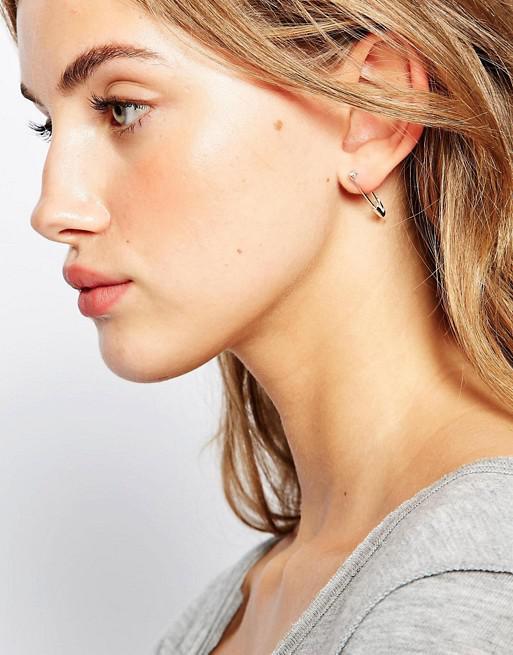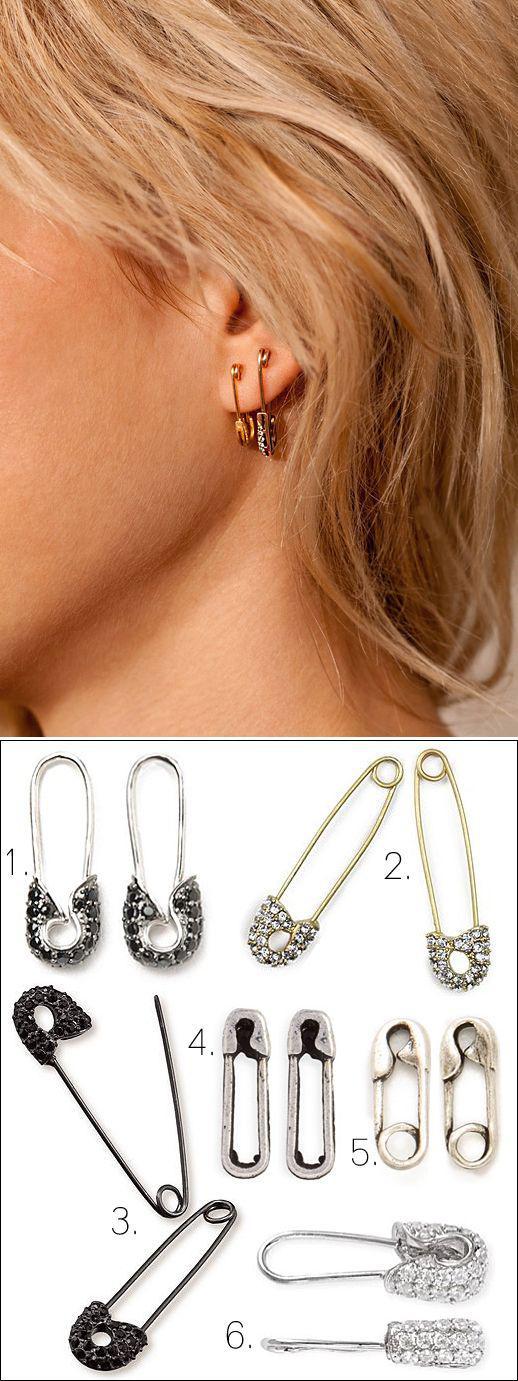The first image is the image on the left, the second image is the image on the right. Given the left and right images, does the statement "A person is wearing a safety pin in their ear in the image on the left." hold true? Answer yes or no. Yes. The first image is the image on the left, the second image is the image on the right. Evaluate the accuracy of this statement regarding the images: "The left image contains a women wearing an ear ring.". Is it true? Answer yes or no. Yes. 